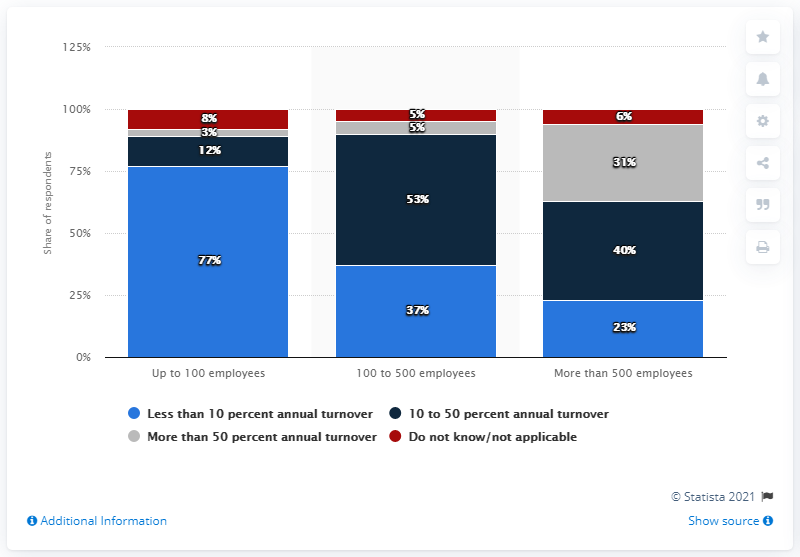Indicate a few pertinent items in this graphic. According to contact center industry leaders, the average annual turnover of representatives exceeds 50%. 